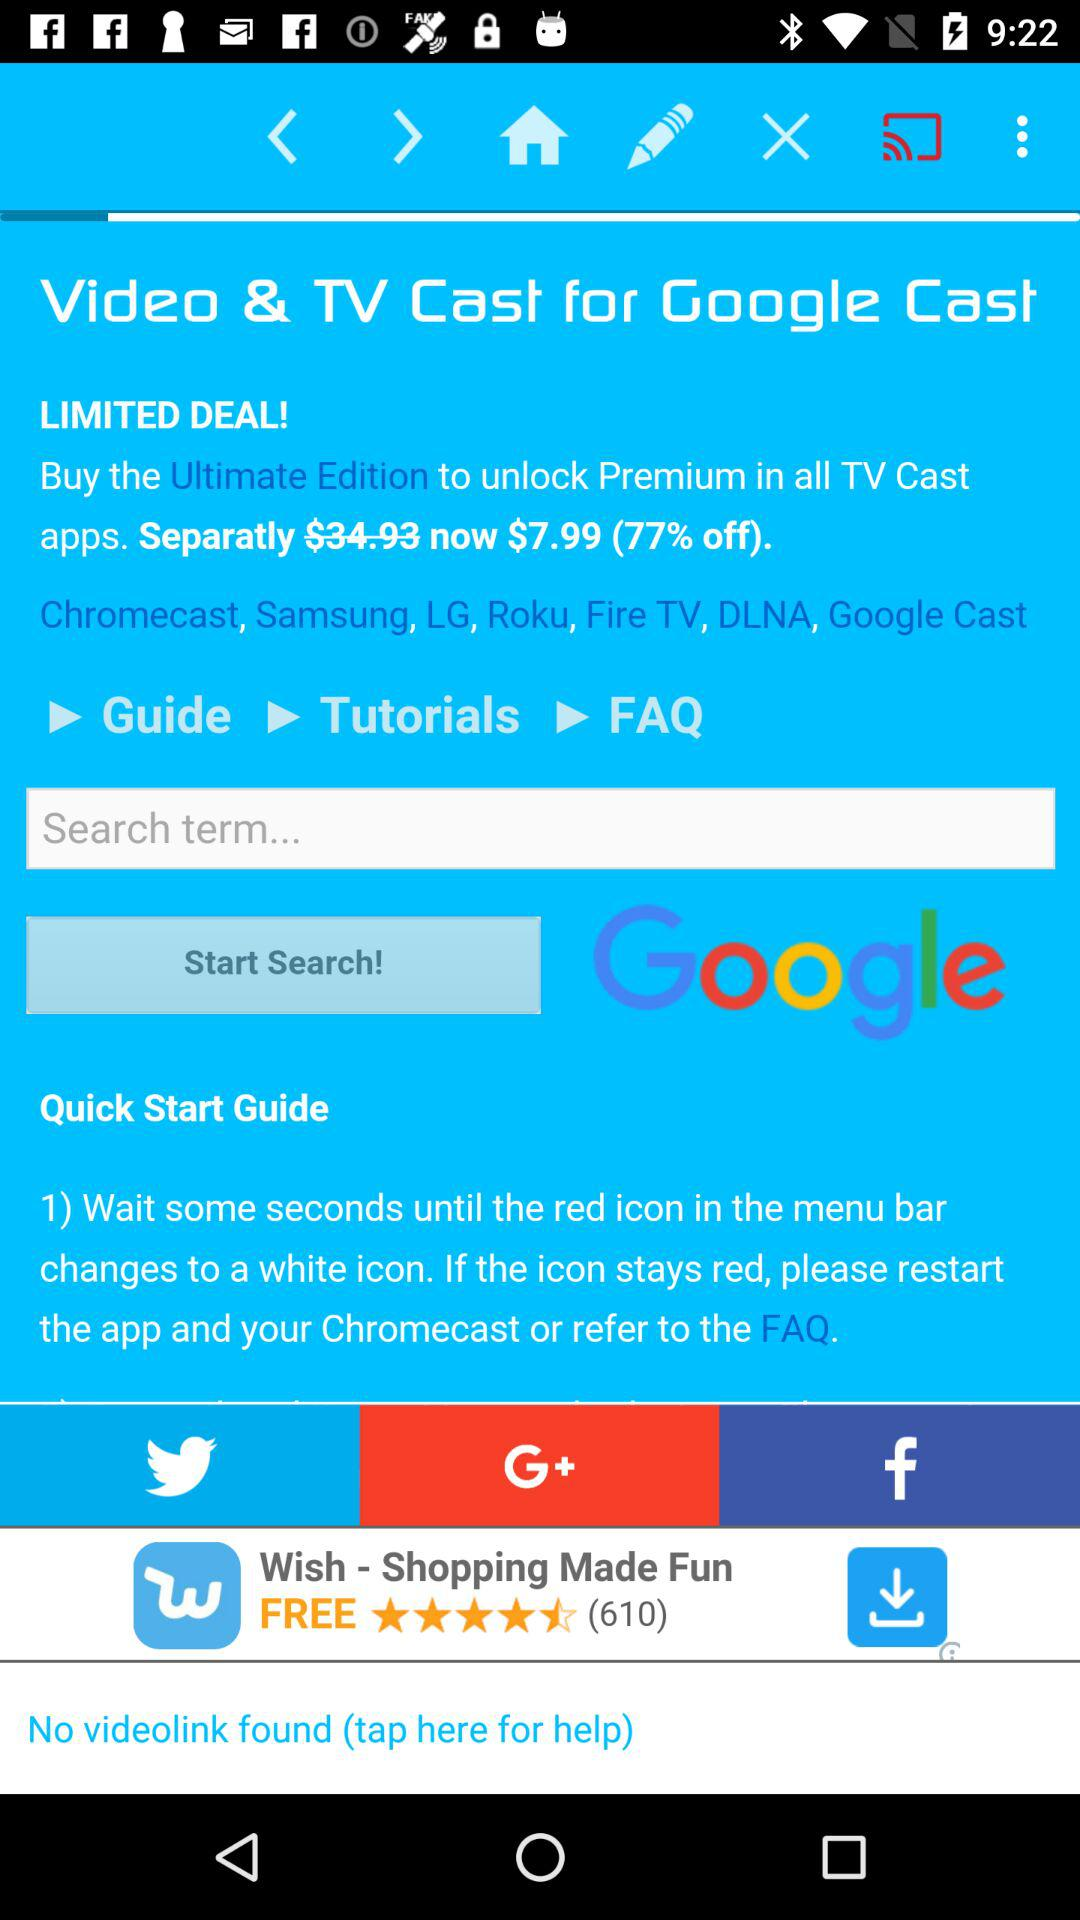What is the cost to unlock premium in the "TV Cast" apps? The cost is $7.99. 